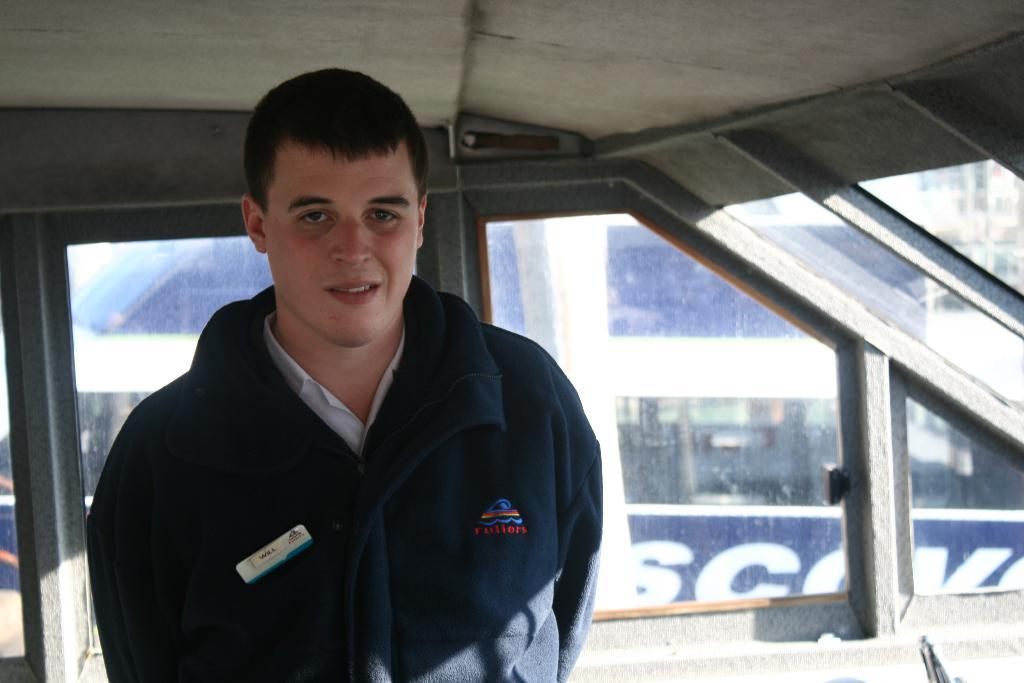What is the main subject of the image? The main subject of the image is a man. Can you describe the man's position in the image? The man is standing in the middle of the image. What is the man's facial expression in the image? The man is smiling in the image. What is the man wearing in the image? The man is wearing a black coat in the image. What type of stitch is the man using to sew the sheet in the image? There is no sheet or stitching present in the image; it features a man standing and smiling. 